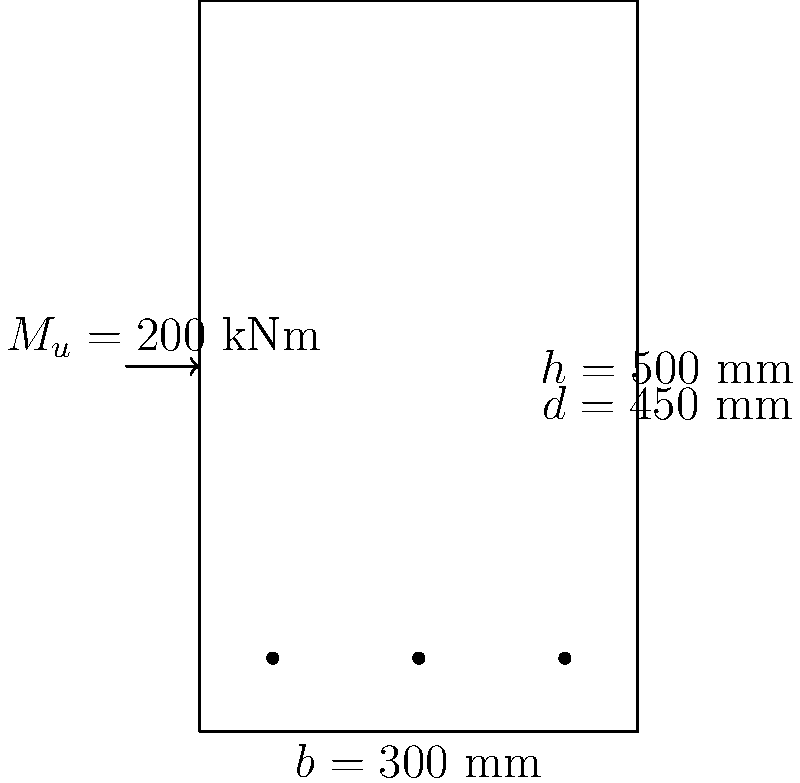Given a rectangular concrete beam section with dimensions $b = 300$ mm, $h = 500$ mm, and $d = 450$ mm, subjected to an ultimate moment $M_u = 200$ kNm, determine the required area of tension reinforcement $A_s$. Assume concrete strength $f_{ck} = 30$ MPa and steel yield strength $f_y = 500$ MPa. Use the simplified rectangular stress block method for analysis. To solve this problem, we'll follow these steps:

1) Calculate the design strength of materials:
   $f_{cd} = 0.67 f_{ck} / 1.5 = 0.67 \times 30 / 1.5 = 13.4$ MPa
   $f_{yd} = f_y / 1.15 = 500 / 1.15 = 434.78$ MPa

2) Calculate the moment of resistance coefficient $K$:
   $K = \frac{M_u}{b d^2 f_{cd}} = \frac{200 \times 10^6}{300 \times 450^2 \times 13.4} = 0.231$

3) Calculate the lever arm coefficient $z$:
   $z = d(0.5 + \sqrt{0.25 - \frac{K}{0.9}}) = 450(0.5 + \sqrt{0.25 - \frac{0.231}{0.9}}) = 389.9$ mm

4) Calculate the area of steel required:
   $A_s = \frac{M_u}{0.87 f_{yd} z} = \frac{200 \times 10^6}{0.87 \times 434.78 \times 389.9} = 1357.8$ mm²

5) Check if the section is under-reinforced:
   $x = \frac{A_s f_{yd}}{0.567 f_{cd} b} = \frac{1357.8 \times 434.78}{0.567 \times 13.4 \times 300} = 185.7$ mm
   $x/d = 185.7 / 450 = 0.413 < 0.45$ (limit for ductile failure)

The section is under-reinforced, so the calculated $A_s$ is valid.
Answer: $A_s = 1357.8$ mm² 